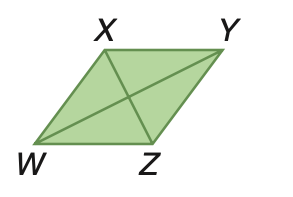Question: Rhombus W X Y Z has an area of 100 square meters. Find W Y if X Z = 10 meters.
Choices:
A. 5
B. 10
C. 20
D. 40
Answer with the letter. Answer: C 